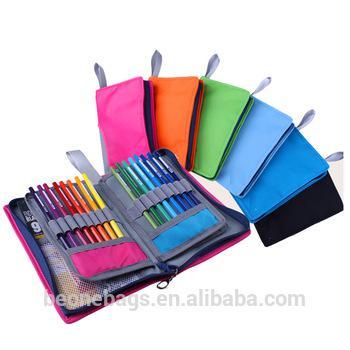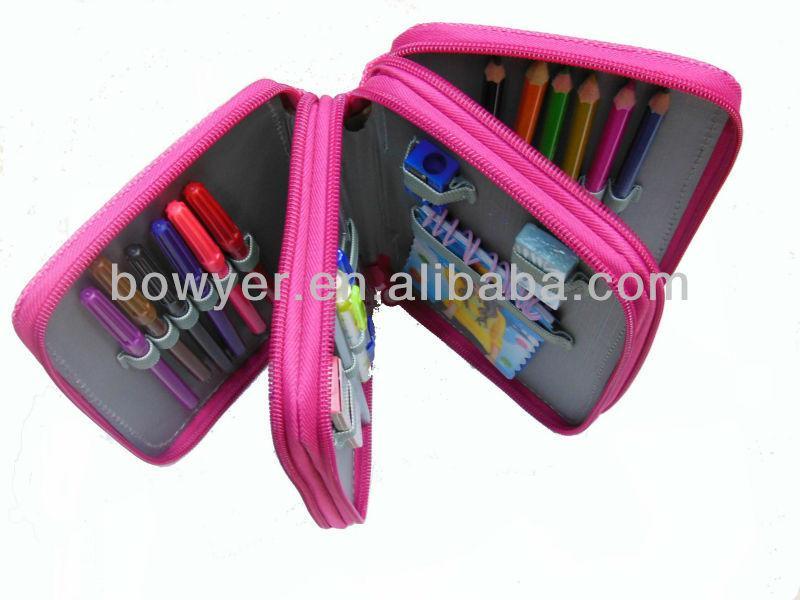The first image is the image on the left, the second image is the image on the right. Evaluate the accuracy of this statement regarding the images: "An image features a bright pink case that is fanned open to reveal multiple sections holding a variety of writing implements.". Is it true? Answer yes or no. Yes. The first image is the image on the left, the second image is the image on the right. Considering the images on both sides, is "There are exactly three pencil cases." valid? Answer yes or no. No. 